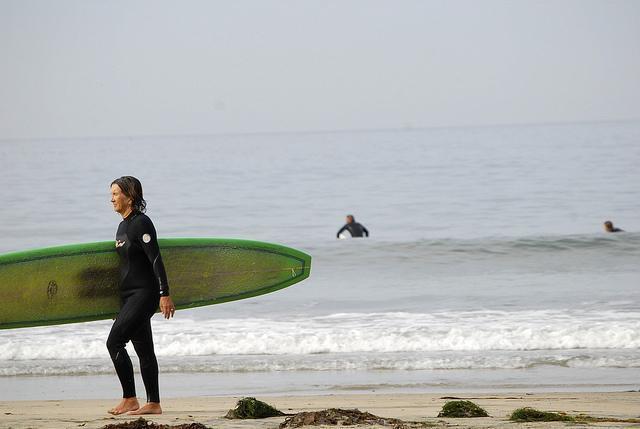How many surfers are shown?
Give a very brief answer. 3. How many people are there?
Give a very brief answer. 1. How many elephants are holding their trunks up in the picture?
Give a very brief answer. 0. 